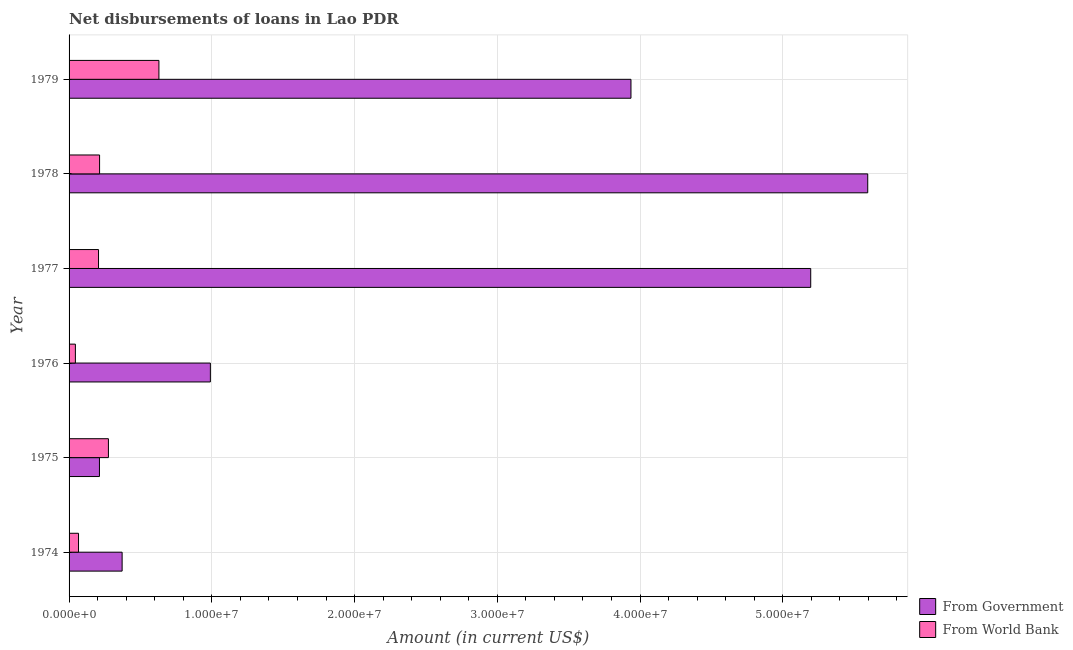Are the number of bars per tick equal to the number of legend labels?
Offer a very short reply. Yes. Are the number of bars on each tick of the Y-axis equal?
Provide a short and direct response. Yes. What is the label of the 6th group of bars from the top?
Offer a very short reply. 1974. What is the net disbursements of loan from world bank in 1978?
Your answer should be compact. 2.14e+06. Across all years, what is the maximum net disbursements of loan from government?
Your answer should be very brief. 5.60e+07. Across all years, what is the minimum net disbursements of loan from world bank?
Make the answer very short. 4.43e+05. In which year was the net disbursements of loan from world bank maximum?
Your answer should be very brief. 1979. In which year was the net disbursements of loan from government minimum?
Provide a succinct answer. 1975. What is the total net disbursements of loan from government in the graph?
Ensure brevity in your answer.  1.63e+08. What is the difference between the net disbursements of loan from world bank in 1975 and that in 1978?
Your response must be concise. 6.20e+05. What is the difference between the net disbursements of loan from world bank in 1979 and the net disbursements of loan from government in 1975?
Make the answer very short. 4.17e+06. What is the average net disbursements of loan from government per year?
Provide a succinct answer. 2.72e+07. In the year 1977, what is the difference between the net disbursements of loan from world bank and net disbursements of loan from government?
Your answer should be very brief. -4.99e+07. In how many years, is the net disbursements of loan from government greater than 14000000 US$?
Offer a terse response. 3. What is the ratio of the net disbursements of loan from world bank in 1975 to that in 1979?
Provide a short and direct response. 0.44. What is the difference between the highest and the second highest net disbursements of loan from government?
Your response must be concise. 3.99e+06. What is the difference between the highest and the lowest net disbursements of loan from world bank?
Your response must be concise. 5.85e+06. In how many years, is the net disbursements of loan from government greater than the average net disbursements of loan from government taken over all years?
Make the answer very short. 3. What does the 2nd bar from the top in 1979 represents?
Your answer should be compact. From Government. What does the 1st bar from the bottom in 1977 represents?
Give a very brief answer. From Government. What is the difference between two consecutive major ticks on the X-axis?
Provide a short and direct response. 1.00e+07. What is the title of the graph?
Offer a very short reply. Net disbursements of loans in Lao PDR. Does "Investment" appear as one of the legend labels in the graph?
Your answer should be very brief. No. What is the label or title of the Y-axis?
Your response must be concise. Year. What is the Amount (in current US$) of From Government in 1974?
Your response must be concise. 3.72e+06. What is the Amount (in current US$) in From World Bank in 1974?
Your answer should be very brief. 6.63e+05. What is the Amount (in current US$) of From Government in 1975?
Give a very brief answer. 2.13e+06. What is the Amount (in current US$) of From World Bank in 1975?
Offer a terse response. 2.76e+06. What is the Amount (in current US$) in From Government in 1976?
Ensure brevity in your answer.  9.90e+06. What is the Amount (in current US$) of From World Bank in 1976?
Offer a very short reply. 4.43e+05. What is the Amount (in current US$) of From Government in 1977?
Offer a terse response. 5.20e+07. What is the Amount (in current US$) in From World Bank in 1977?
Your answer should be compact. 2.06e+06. What is the Amount (in current US$) of From Government in 1978?
Give a very brief answer. 5.60e+07. What is the Amount (in current US$) of From World Bank in 1978?
Give a very brief answer. 2.14e+06. What is the Amount (in current US$) in From Government in 1979?
Your answer should be very brief. 3.94e+07. What is the Amount (in current US$) of From World Bank in 1979?
Keep it short and to the point. 6.30e+06. Across all years, what is the maximum Amount (in current US$) in From Government?
Your answer should be very brief. 5.60e+07. Across all years, what is the maximum Amount (in current US$) in From World Bank?
Provide a succinct answer. 6.30e+06. Across all years, what is the minimum Amount (in current US$) of From Government?
Give a very brief answer. 2.13e+06. Across all years, what is the minimum Amount (in current US$) in From World Bank?
Your response must be concise. 4.43e+05. What is the total Amount (in current US$) of From Government in the graph?
Provide a succinct answer. 1.63e+08. What is the total Amount (in current US$) of From World Bank in the graph?
Make the answer very short. 1.44e+07. What is the difference between the Amount (in current US$) of From Government in 1974 and that in 1975?
Provide a succinct answer. 1.59e+06. What is the difference between the Amount (in current US$) of From World Bank in 1974 and that in 1975?
Provide a short and direct response. -2.09e+06. What is the difference between the Amount (in current US$) in From Government in 1974 and that in 1976?
Provide a short and direct response. -6.18e+06. What is the difference between the Amount (in current US$) of From World Bank in 1974 and that in 1976?
Keep it short and to the point. 2.20e+05. What is the difference between the Amount (in current US$) of From Government in 1974 and that in 1977?
Provide a succinct answer. -4.82e+07. What is the difference between the Amount (in current US$) of From World Bank in 1974 and that in 1977?
Your answer should be compact. -1.40e+06. What is the difference between the Amount (in current US$) in From Government in 1974 and that in 1978?
Make the answer very short. -5.22e+07. What is the difference between the Amount (in current US$) in From World Bank in 1974 and that in 1978?
Your answer should be compact. -1.47e+06. What is the difference between the Amount (in current US$) in From Government in 1974 and that in 1979?
Provide a short and direct response. -3.56e+07. What is the difference between the Amount (in current US$) in From World Bank in 1974 and that in 1979?
Your answer should be compact. -5.63e+06. What is the difference between the Amount (in current US$) of From Government in 1975 and that in 1976?
Your response must be concise. -7.77e+06. What is the difference between the Amount (in current US$) of From World Bank in 1975 and that in 1976?
Offer a very short reply. 2.31e+06. What is the difference between the Amount (in current US$) of From Government in 1975 and that in 1977?
Provide a short and direct response. -4.98e+07. What is the difference between the Amount (in current US$) in From World Bank in 1975 and that in 1977?
Give a very brief answer. 6.93e+05. What is the difference between the Amount (in current US$) in From Government in 1975 and that in 1978?
Your answer should be very brief. -5.38e+07. What is the difference between the Amount (in current US$) of From World Bank in 1975 and that in 1978?
Offer a very short reply. 6.20e+05. What is the difference between the Amount (in current US$) of From Government in 1975 and that in 1979?
Offer a very short reply. -3.72e+07. What is the difference between the Amount (in current US$) of From World Bank in 1975 and that in 1979?
Give a very brief answer. -3.54e+06. What is the difference between the Amount (in current US$) of From Government in 1976 and that in 1977?
Your response must be concise. -4.21e+07. What is the difference between the Amount (in current US$) of From World Bank in 1976 and that in 1977?
Offer a very short reply. -1.62e+06. What is the difference between the Amount (in current US$) in From Government in 1976 and that in 1978?
Keep it short and to the point. -4.61e+07. What is the difference between the Amount (in current US$) in From World Bank in 1976 and that in 1978?
Make the answer very short. -1.69e+06. What is the difference between the Amount (in current US$) in From Government in 1976 and that in 1979?
Make the answer very short. -2.95e+07. What is the difference between the Amount (in current US$) in From World Bank in 1976 and that in 1979?
Give a very brief answer. -5.85e+06. What is the difference between the Amount (in current US$) in From Government in 1977 and that in 1978?
Your response must be concise. -3.99e+06. What is the difference between the Amount (in current US$) in From World Bank in 1977 and that in 1978?
Provide a short and direct response. -7.30e+04. What is the difference between the Amount (in current US$) of From Government in 1977 and that in 1979?
Ensure brevity in your answer.  1.26e+07. What is the difference between the Amount (in current US$) in From World Bank in 1977 and that in 1979?
Ensure brevity in your answer.  -4.23e+06. What is the difference between the Amount (in current US$) in From Government in 1978 and that in 1979?
Your response must be concise. 1.66e+07. What is the difference between the Amount (in current US$) of From World Bank in 1978 and that in 1979?
Your answer should be very brief. -4.16e+06. What is the difference between the Amount (in current US$) in From Government in 1974 and the Amount (in current US$) in From World Bank in 1975?
Keep it short and to the point. 9.60e+05. What is the difference between the Amount (in current US$) of From Government in 1974 and the Amount (in current US$) of From World Bank in 1976?
Your response must be concise. 3.27e+06. What is the difference between the Amount (in current US$) in From Government in 1974 and the Amount (in current US$) in From World Bank in 1977?
Keep it short and to the point. 1.65e+06. What is the difference between the Amount (in current US$) in From Government in 1974 and the Amount (in current US$) in From World Bank in 1978?
Your answer should be compact. 1.58e+06. What is the difference between the Amount (in current US$) of From Government in 1974 and the Amount (in current US$) of From World Bank in 1979?
Ensure brevity in your answer.  -2.58e+06. What is the difference between the Amount (in current US$) in From Government in 1975 and the Amount (in current US$) in From World Bank in 1976?
Provide a succinct answer. 1.69e+06. What is the difference between the Amount (in current US$) in From Government in 1975 and the Amount (in current US$) in From World Bank in 1977?
Your answer should be very brief. 6.50e+04. What is the difference between the Amount (in current US$) of From Government in 1975 and the Amount (in current US$) of From World Bank in 1978?
Keep it short and to the point. -8000. What is the difference between the Amount (in current US$) in From Government in 1975 and the Amount (in current US$) in From World Bank in 1979?
Keep it short and to the point. -4.17e+06. What is the difference between the Amount (in current US$) in From Government in 1976 and the Amount (in current US$) in From World Bank in 1977?
Provide a succinct answer. 7.84e+06. What is the difference between the Amount (in current US$) of From Government in 1976 and the Amount (in current US$) of From World Bank in 1978?
Offer a very short reply. 7.76e+06. What is the difference between the Amount (in current US$) of From Government in 1976 and the Amount (in current US$) of From World Bank in 1979?
Your response must be concise. 3.60e+06. What is the difference between the Amount (in current US$) of From Government in 1977 and the Amount (in current US$) of From World Bank in 1978?
Give a very brief answer. 4.98e+07. What is the difference between the Amount (in current US$) of From Government in 1977 and the Amount (in current US$) of From World Bank in 1979?
Make the answer very short. 4.57e+07. What is the difference between the Amount (in current US$) in From Government in 1978 and the Amount (in current US$) in From World Bank in 1979?
Offer a very short reply. 4.97e+07. What is the average Amount (in current US$) in From Government per year?
Your answer should be very brief. 2.72e+07. What is the average Amount (in current US$) in From World Bank per year?
Make the answer very short. 2.39e+06. In the year 1974, what is the difference between the Amount (in current US$) of From Government and Amount (in current US$) of From World Bank?
Keep it short and to the point. 3.05e+06. In the year 1975, what is the difference between the Amount (in current US$) of From Government and Amount (in current US$) of From World Bank?
Keep it short and to the point. -6.28e+05. In the year 1976, what is the difference between the Amount (in current US$) in From Government and Amount (in current US$) in From World Bank?
Provide a short and direct response. 9.46e+06. In the year 1977, what is the difference between the Amount (in current US$) of From Government and Amount (in current US$) of From World Bank?
Your response must be concise. 4.99e+07. In the year 1978, what is the difference between the Amount (in current US$) of From Government and Amount (in current US$) of From World Bank?
Ensure brevity in your answer.  5.38e+07. In the year 1979, what is the difference between the Amount (in current US$) of From Government and Amount (in current US$) of From World Bank?
Provide a succinct answer. 3.31e+07. What is the ratio of the Amount (in current US$) of From Government in 1974 to that in 1975?
Give a very brief answer. 1.75. What is the ratio of the Amount (in current US$) in From World Bank in 1974 to that in 1975?
Make the answer very short. 0.24. What is the ratio of the Amount (in current US$) in From Government in 1974 to that in 1976?
Keep it short and to the point. 0.38. What is the ratio of the Amount (in current US$) in From World Bank in 1974 to that in 1976?
Offer a very short reply. 1.5. What is the ratio of the Amount (in current US$) of From Government in 1974 to that in 1977?
Offer a very short reply. 0.07. What is the ratio of the Amount (in current US$) in From World Bank in 1974 to that in 1977?
Ensure brevity in your answer.  0.32. What is the ratio of the Amount (in current US$) of From Government in 1974 to that in 1978?
Make the answer very short. 0.07. What is the ratio of the Amount (in current US$) of From World Bank in 1974 to that in 1978?
Keep it short and to the point. 0.31. What is the ratio of the Amount (in current US$) in From Government in 1974 to that in 1979?
Your response must be concise. 0.09. What is the ratio of the Amount (in current US$) in From World Bank in 1974 to that in 1979?
Provide a succinct answer. 0.11. What is the ratio of the Amount (in current US$) of From Government in 1975 to that in 1976?
Your answer should be compact. 0.22. What is the ratio of the Amount (in current US$) in From World Bank in 1975 to that in 1976?
Your response must be concise. 6.22. What is the ratio of the Amount (in current US$) in From Government in 1975 to that in 1977?
Your response must be concise. 0.04. What is the ratio of the Amount (in current US$) in From World Bank in 1975 to that in 1977?
Provide a succinct answer. 1.34. What is the ratio of the Amount (in current US$) in From Government in 1975 to that in 1978?
Provide a succinct answer. 0.04. What is the ratio of the Amount (in current US$) of From World Bank in 1975 to that in 1978?
Your answer should be very brief. 1.29. What is the ratio of the Amount (in current US$) of From Government in 1975 to that in 1979?
Your answer should be compact. 0.05. What is the ratio of the Amount (in current US$) in From World Bank in 1975 to that in 1979?
Your answer should be compact. 0.44. What is the ratio of the Amount (in current US$) of From Government in 1976 to that in 1977?
Offer a terse response. 0.19. What is the ratio of the Amount (in current US$) in From World Bank in 1976 to that in 1977?
Provide a succinct answer. 0.21. What is the ratio of the Amount (in current US$) of From Government in 1976 to that in 1978?
Offer a very short reply. 0.18. What is the ratio of the Amount (in current US$) of From World Bank in 1976 to that in 1978?
Give a very brief answer. 0.21. What is the ratio of the Amount (in current US$) in From Government in 1976 to that in 1979?
Offer a very short reply. 0.25. What is the ratio of the Amount (in current US$) in From World Bank in 1976 to that in 1979?
Offer a terse response. 0.07. What is the ratio of the Amount (in current US$) in From Government in 1977 to that in 1978?
Offer a terse response. 0.93. What is the ratio of the Amount (in current US$) of From World Bank in 1977 to that in 1978?
Make the answer very short. 0.97. What is the ratio of the Amount (in current US$) of From Government in 1977 to that in 1979?
Give a very brief answer. 1.32. What is the ratio of the Amount (in current US$) of From World Bank in 1977 to that in 1979?
Provide a short and direct response. 0.33. What is the ratio of the Amount (in current US$) of From Government in 1978 to that in 1979?
Provide a succinct answer. 1.42. What is the ratio of the Amount (in current US$) in From World Bank in 1978 to that in 1979?
Provide a succinct answer. 0.34. What is the difference between the highest and the second highest Amount (in current US$) in From Government?
Offer a very short reply. 3.99e+06. What is the difference between the highest and the second highest Amount (in current US$) in From World Bank?
Offer a very short reply. 3.54e+06. What is the difference between the highest and the lowest Amount (in current US$) of From Government?
Offer a very short reply. 5.38e+07. What is the difference between the highest and the lowest Amount (in current US$) of From World Bank?
Make the answer very short. 5.85e+06. 